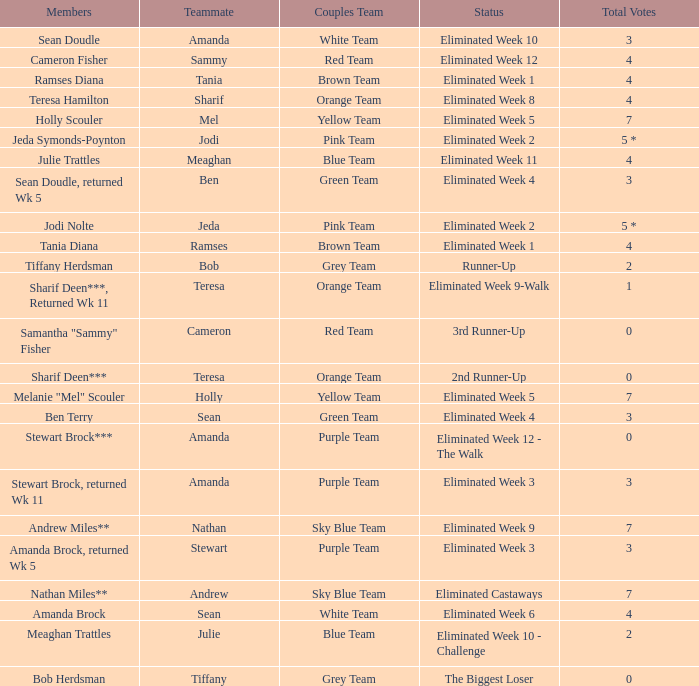Who had 0 total votes in the purple team? Eliminated Week 12 - The Walk. 